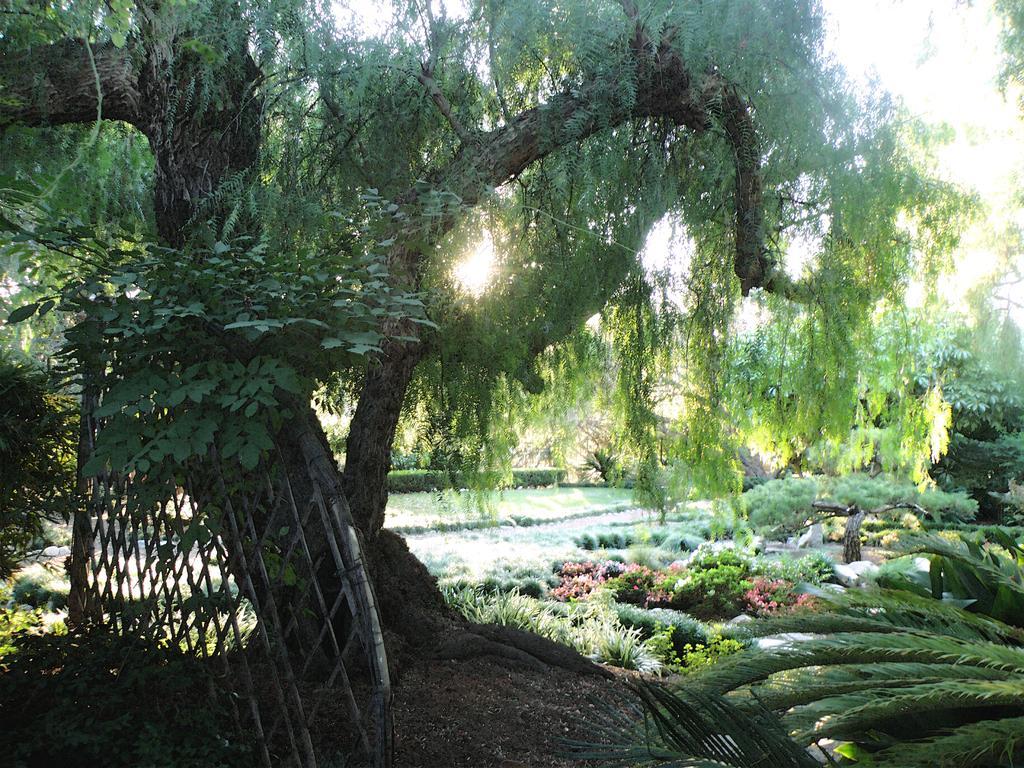Describe this image in one or two sentences. In front of the image there is a tree, in front of the tree there is a wooden fence, in the background of the image there are flowers, plants, leaves and bushes. 